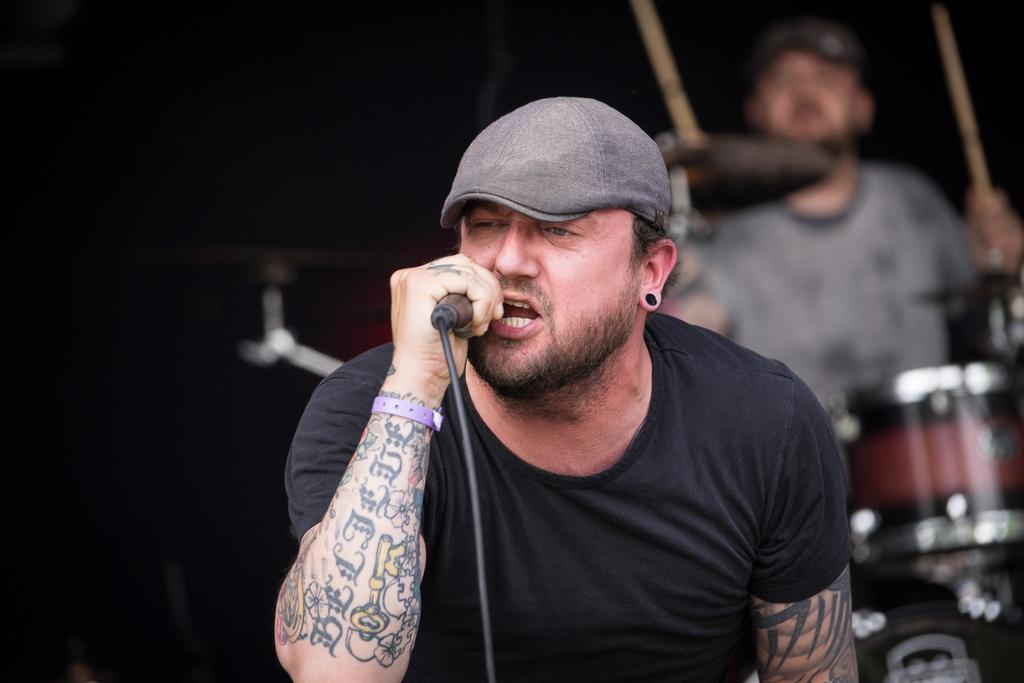Describe this image in one or two sentences. In this picture there is singer and a musician. The man in the center is wearing a black T-shirt, a cap and a earring. He is holding a microphone in his hands. He has tattoos on his both hands. The man behind him is playing drums and holding sticks in his hands. 